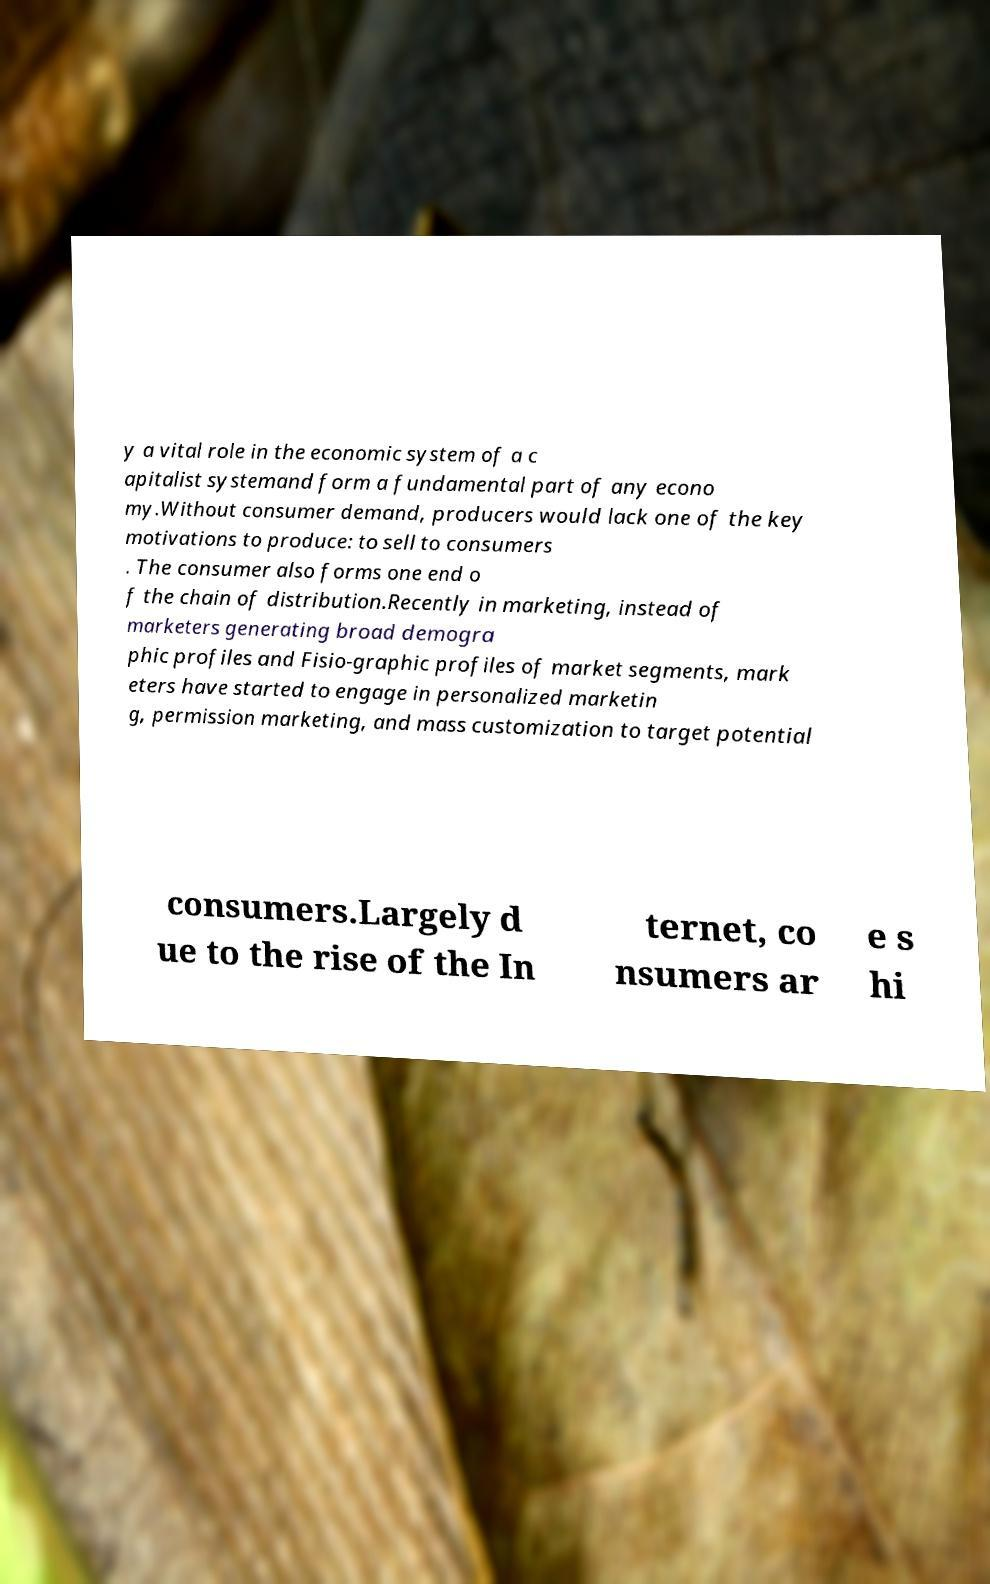There's text embedded in this image that I need extracted. Can you transcribe it verbatim? y a vital role in the economic system of a c apitalist systemand form a fundamental part of any econo my.Without consumer demand, producers would lack one of the key motivations to produce: to sell to consumers . The consumer also forms one end o f the chain of distribution.Recently in marketing, instead of marketers generating broad demogra phic profiles and Fisio-graphic profiles of market segments, mark eters have started to engage in personalized marketin g, permission marketing, and mass customization to target potential consumers.Largely d ue to the rise of the In ternet, co nsumers ar e s hi 